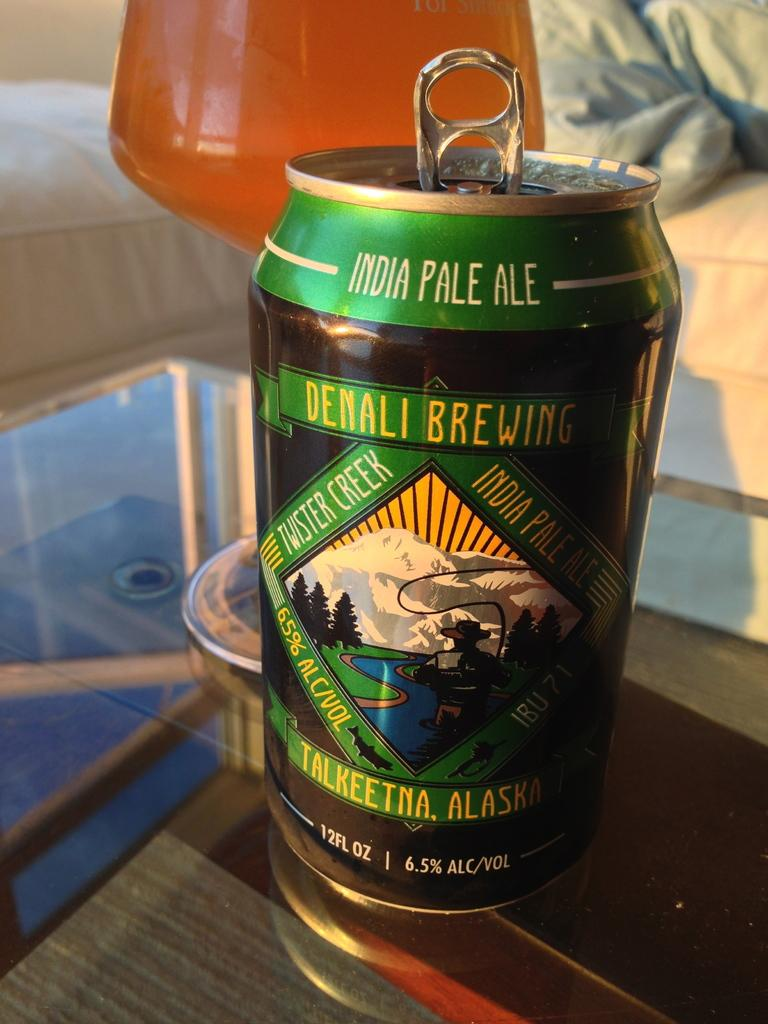Provide a one-sentence caption for the provided image. A can of India Pale Ale placed on top of a glass table. 